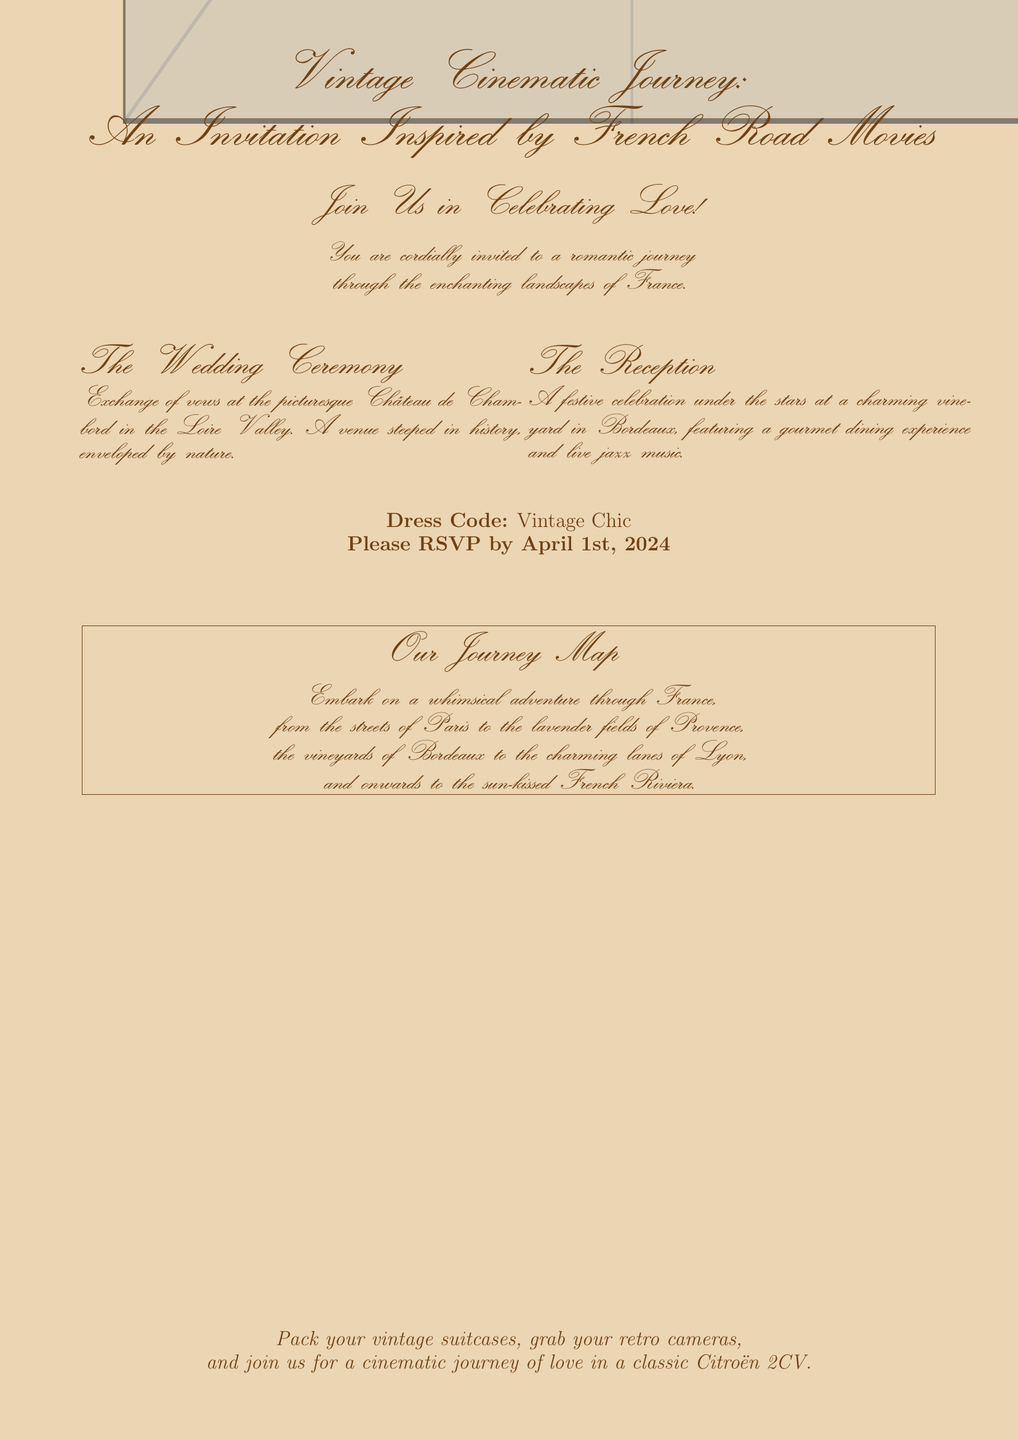What is the title of the invitation? The title reflects the theme of the wedding and is prominently displayed at the top of the document.
Answer: Vintage Cinematic Journey: An Invitation Inspired by French Road Movies What is the wedding ceremony venue? The venue information is listed in the section dedicated to the wedding ceremony details.
Answer: Château de Chambord What is the dress code? The dress code is specified clearly towards the end of the invitation.
Answer: Vintage Chic What date should guests RSVP by? The RSVP date is mentioned clearly in the body of the invitation.
Answer: April 1st, 2024 What is the main theme of the wedding invitation? The main theme is based on inspiring elements from classic French cinema, specifically road movies.
Answer: French road movies Which city is noted for its lavender fields in the journey map? The document mentions different locations that the journey map covers, including this specific city.
Answer: Provence What type of music will be played at the reception? This detail is highlighted in the section describing the reception festivities.
Answer: Live jazz music How are guests invited to celebrate love? The invitation uses a warm and welcoming phrase to draw guests into the experience.
Answer: Join Us in Celebrating Love! 